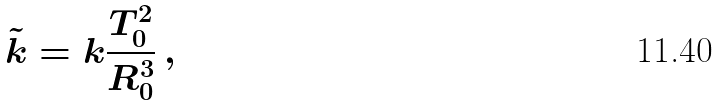Convert formula to latex. <formula><loc_0><loc_0><loc_500><loc_500>\tilde { k } = k \frac { T _ { 0 } ^ { 2 } } { R _ { 0 } ^ { 3 } } \, ,</formula> 